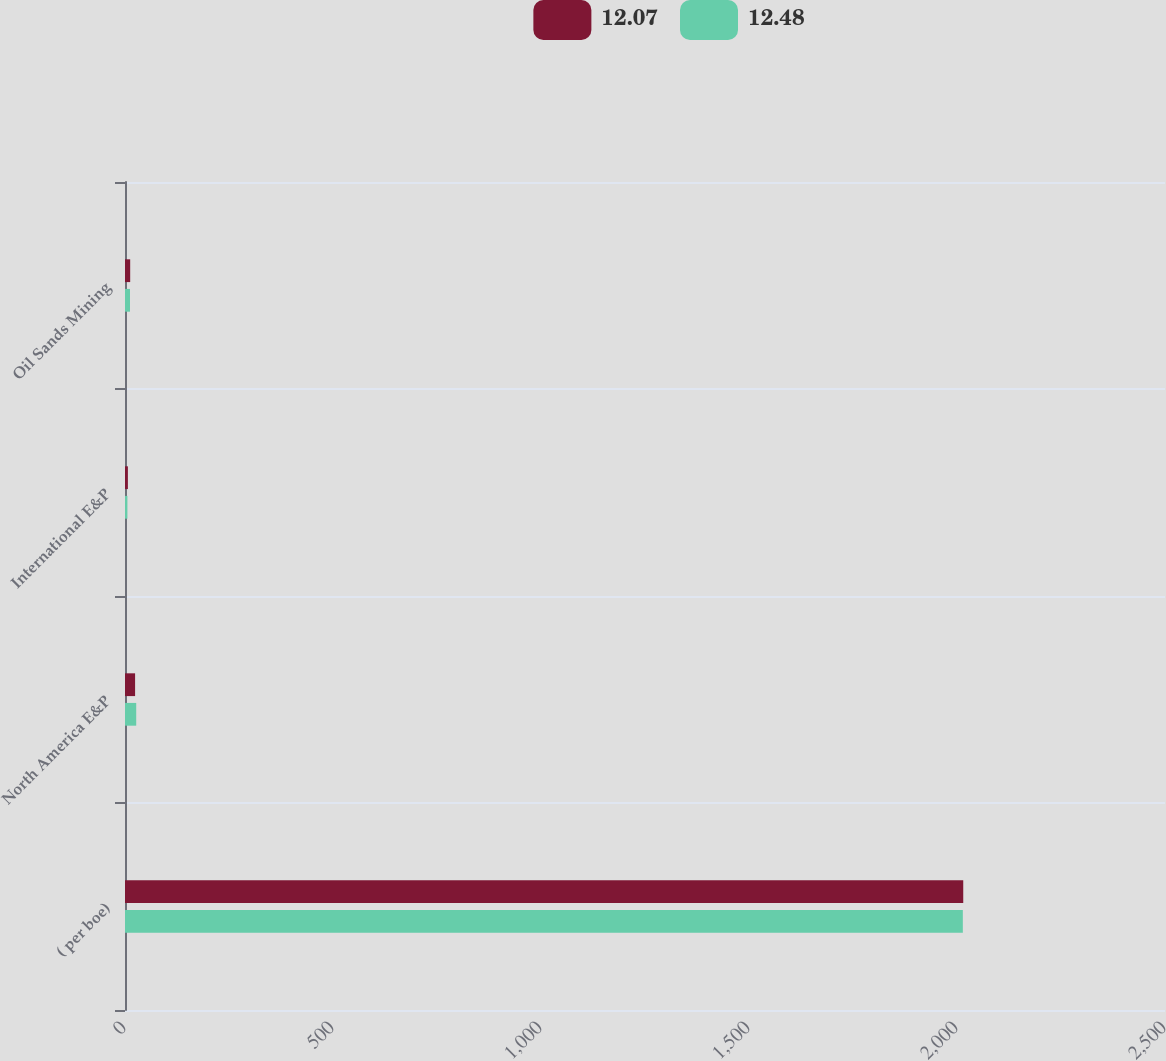<chart> <loc_0><loc_0><loc_500><loc_500><stacked_bar_chart><ecel><fcel>( per boe)<fcel>North America E&P<fcel>International E&P<fcel>Oil Sands Mining<nl><fcel>12.07<fcel>2015<fcel>24.24<fcel>6.95<fcel>12.48<nl><fcel>12.48<fcel>2014<fcel>26.95<fcel>5.79<fcel>12.07<nl></chart> 